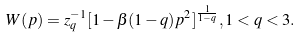<formula> <loc_0><loc_0><loc_500><loc_500>W ( p ) = z _ { q } ^ { - 1 } [ 1 - \beta ( 1 - q ) p ^ { 2 } ] ^ { \frac { 1 } { 1 - q } } , 1 < q < 3 .</formula> 